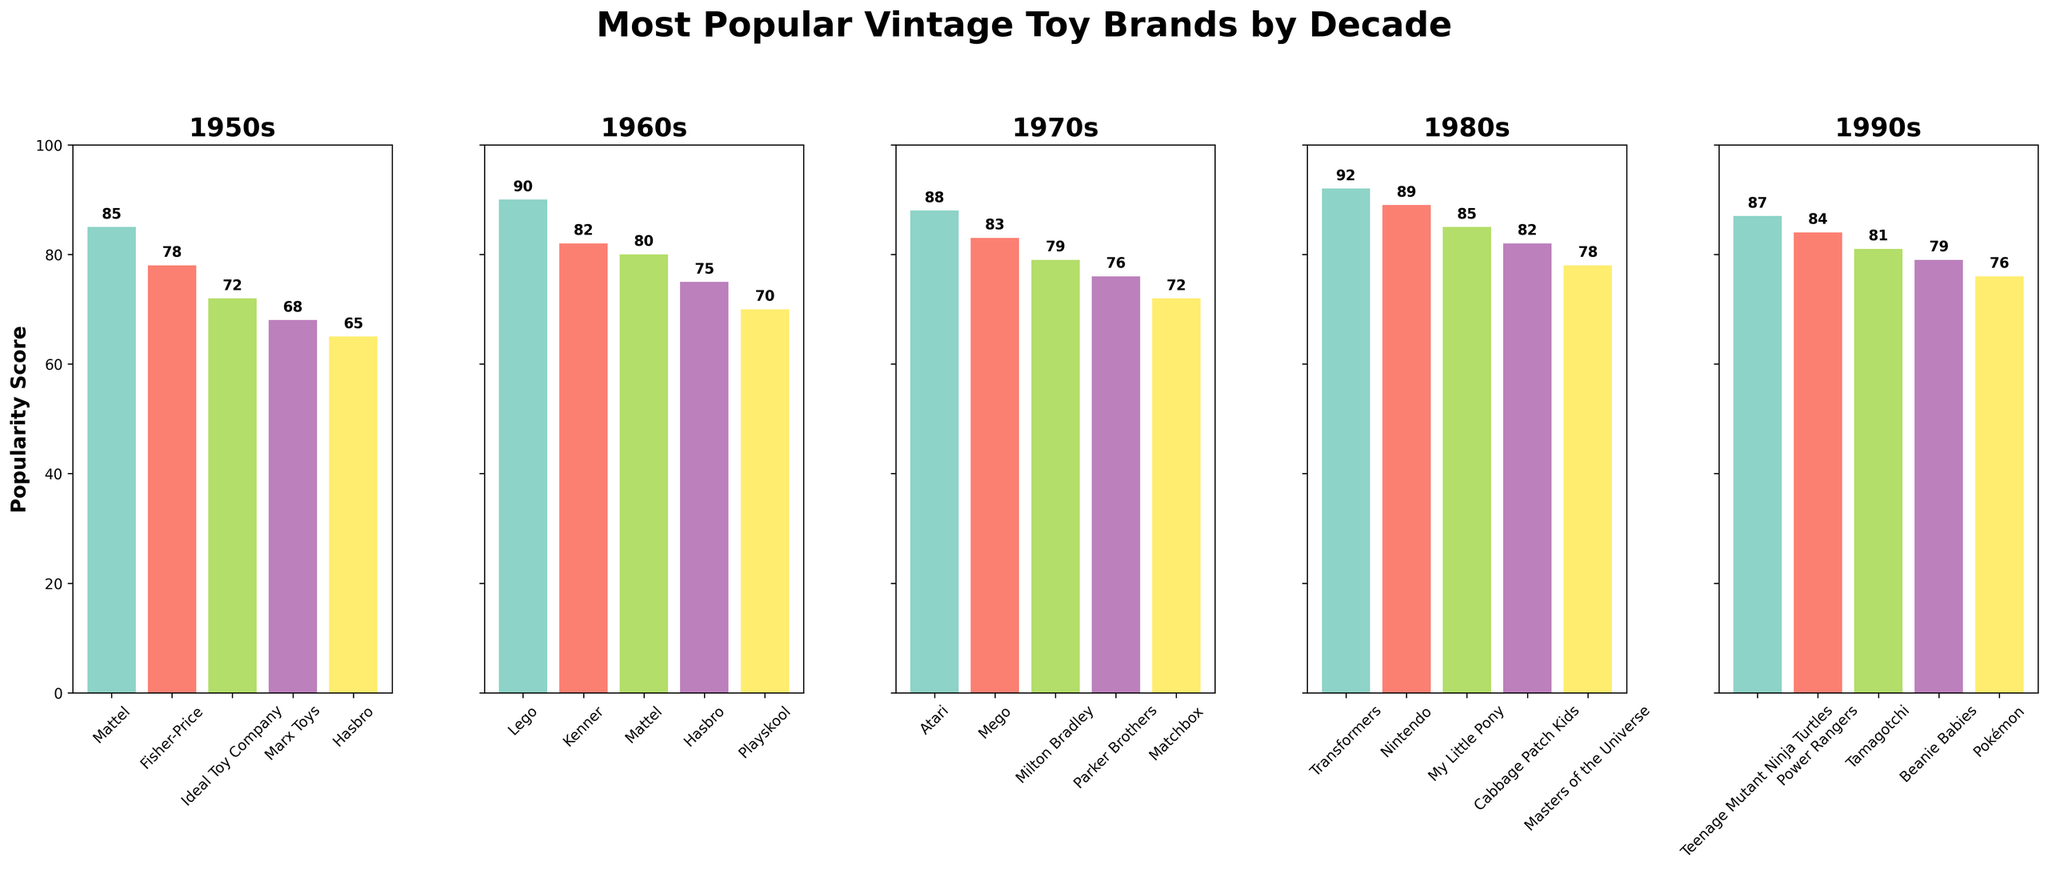Which brand was the most popular in the 1960s? Look at the 1960s segment of the chart. The tallest bar indicates the most popular brand, which is Lego with a popularity score of 90.
Answer: Lego Which decades did Mattel appear in the top 5 most popular brands? Examine each segment (decade) for the presence of Mattel. Mattel appears in the 1950s and 1960s.
Answer: 1950s, 1960s Which decade shows the highest overall popularity score for the most popular brand? Compare the tallest bars in each decade. The highest overall score is in the 1980s with a score of 92 for Transformers.
Answer: 1980s What is the difference in popularity score between Atari and Milton Bradley in the 1970s? Find the heights of the bars for Atari (88) and Milton Bradley (79) in the 1970s segment and subtract the lower score from the higher score, 88 - 79 = 9.
Answer: 9 How many brands in the 1990s have a popularity score over 80? Count the bars in the 1990s segment that have a score above 80. There are four brands: Teenage Mutant Ninja Turtles (87), Power Rangers (84), Tamagotchi (81), and Beanie Babies (79).
Answer: 4 Which brands in the 1980s have a higher popularity score than My Little Pony? In the 1980s segment, identify the brands with taller bars than My Little Pony (score 85). The brands are Transformers (92) and Nintendo (89).
Answer: Transformers, Nintendo What is the average popularity score of the top 5 brands in the 1950s? Add the popularity scores of the top 5 brands in the 1950s: Mattel (85), Fisher-Price (78), Ideal Toy Company (72), Marx Toys (68), and Hasbro (65), then divide by 5. (85 + 78 + 72 + 68 + 65) / 5 = 368 / 5 = 73.6.
Answer: 73.6 How many times did Hasbro appear as a top 5 brand from the 1950s to the 1990s? Count the segments (decades) where Hasbro is present in the top 5. Hasbro appears in the 1950s (65) and 1960s (75).
Answer: 2 Which decade has the lowest popularity score for the top brand and what is that score? Find the shortest bar among the tallest bars for each decade. The 1950s has the lowest score for the top brand, which is Mattel with a score of 85.
Answer: 1950s, 85 